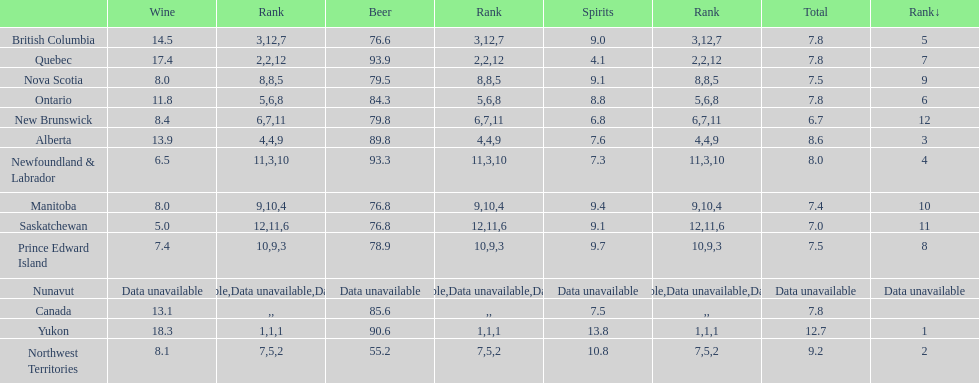Tell me province that drank more than 15 liters of wine. Yukon, Quebec. 